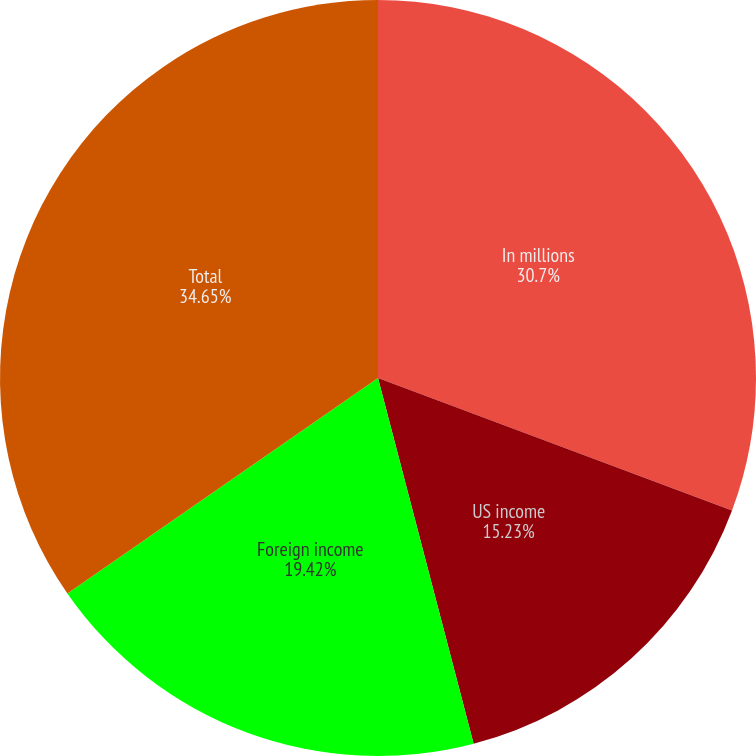<chart> <loc_0><loc_0><loc_500><loc_500><pie_chart><fcel>In millions<fcel>US income<fcel>Foreign income<fcel>Total<nl><fcel>30.7%<fcel>15.23%<fcel>19.42%<fcel>34.65%<nl></chart> 